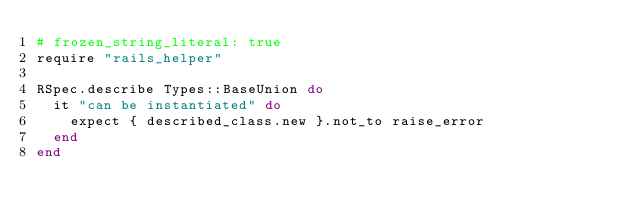<code> <loc_0><loc_0><loc_500><loc_500><_Ruby_># frozen_string_literal: true
require "rails_helper"

RSpec.describe Types::BaseUnion do
  it "can be instantiated" do
    expect { described_class.new }.not_to raise_error
  end
end
</code> 